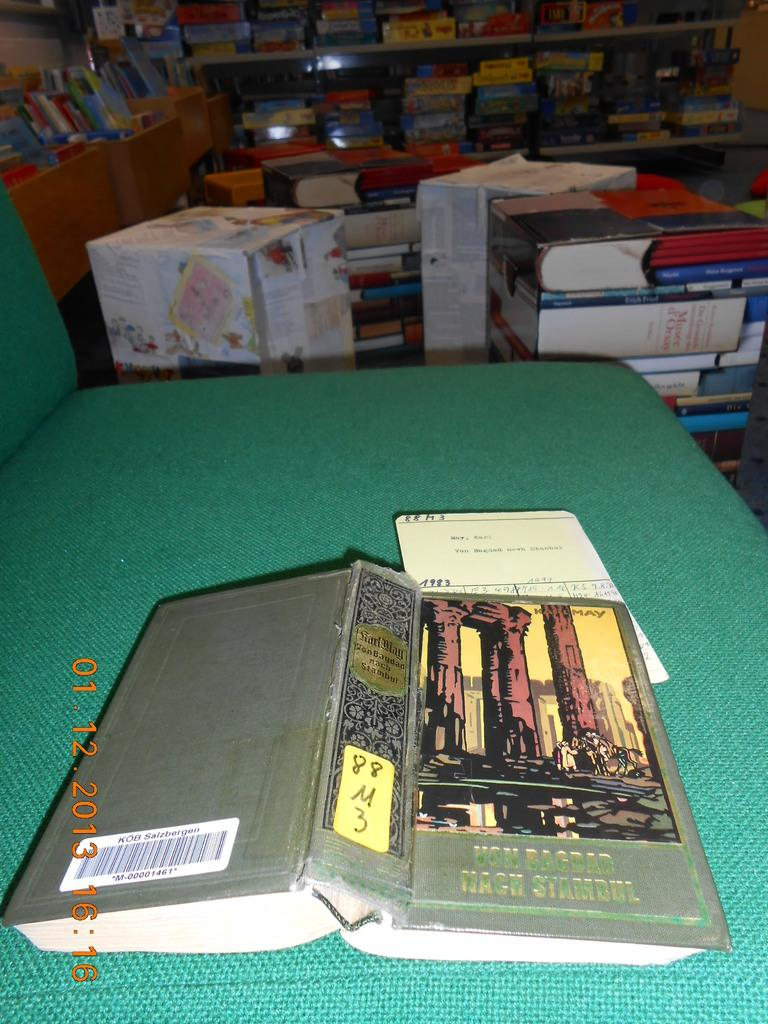<image>
Provide a brief description of the given image. Book facing downwards with the numbers M00001461 on the back. 